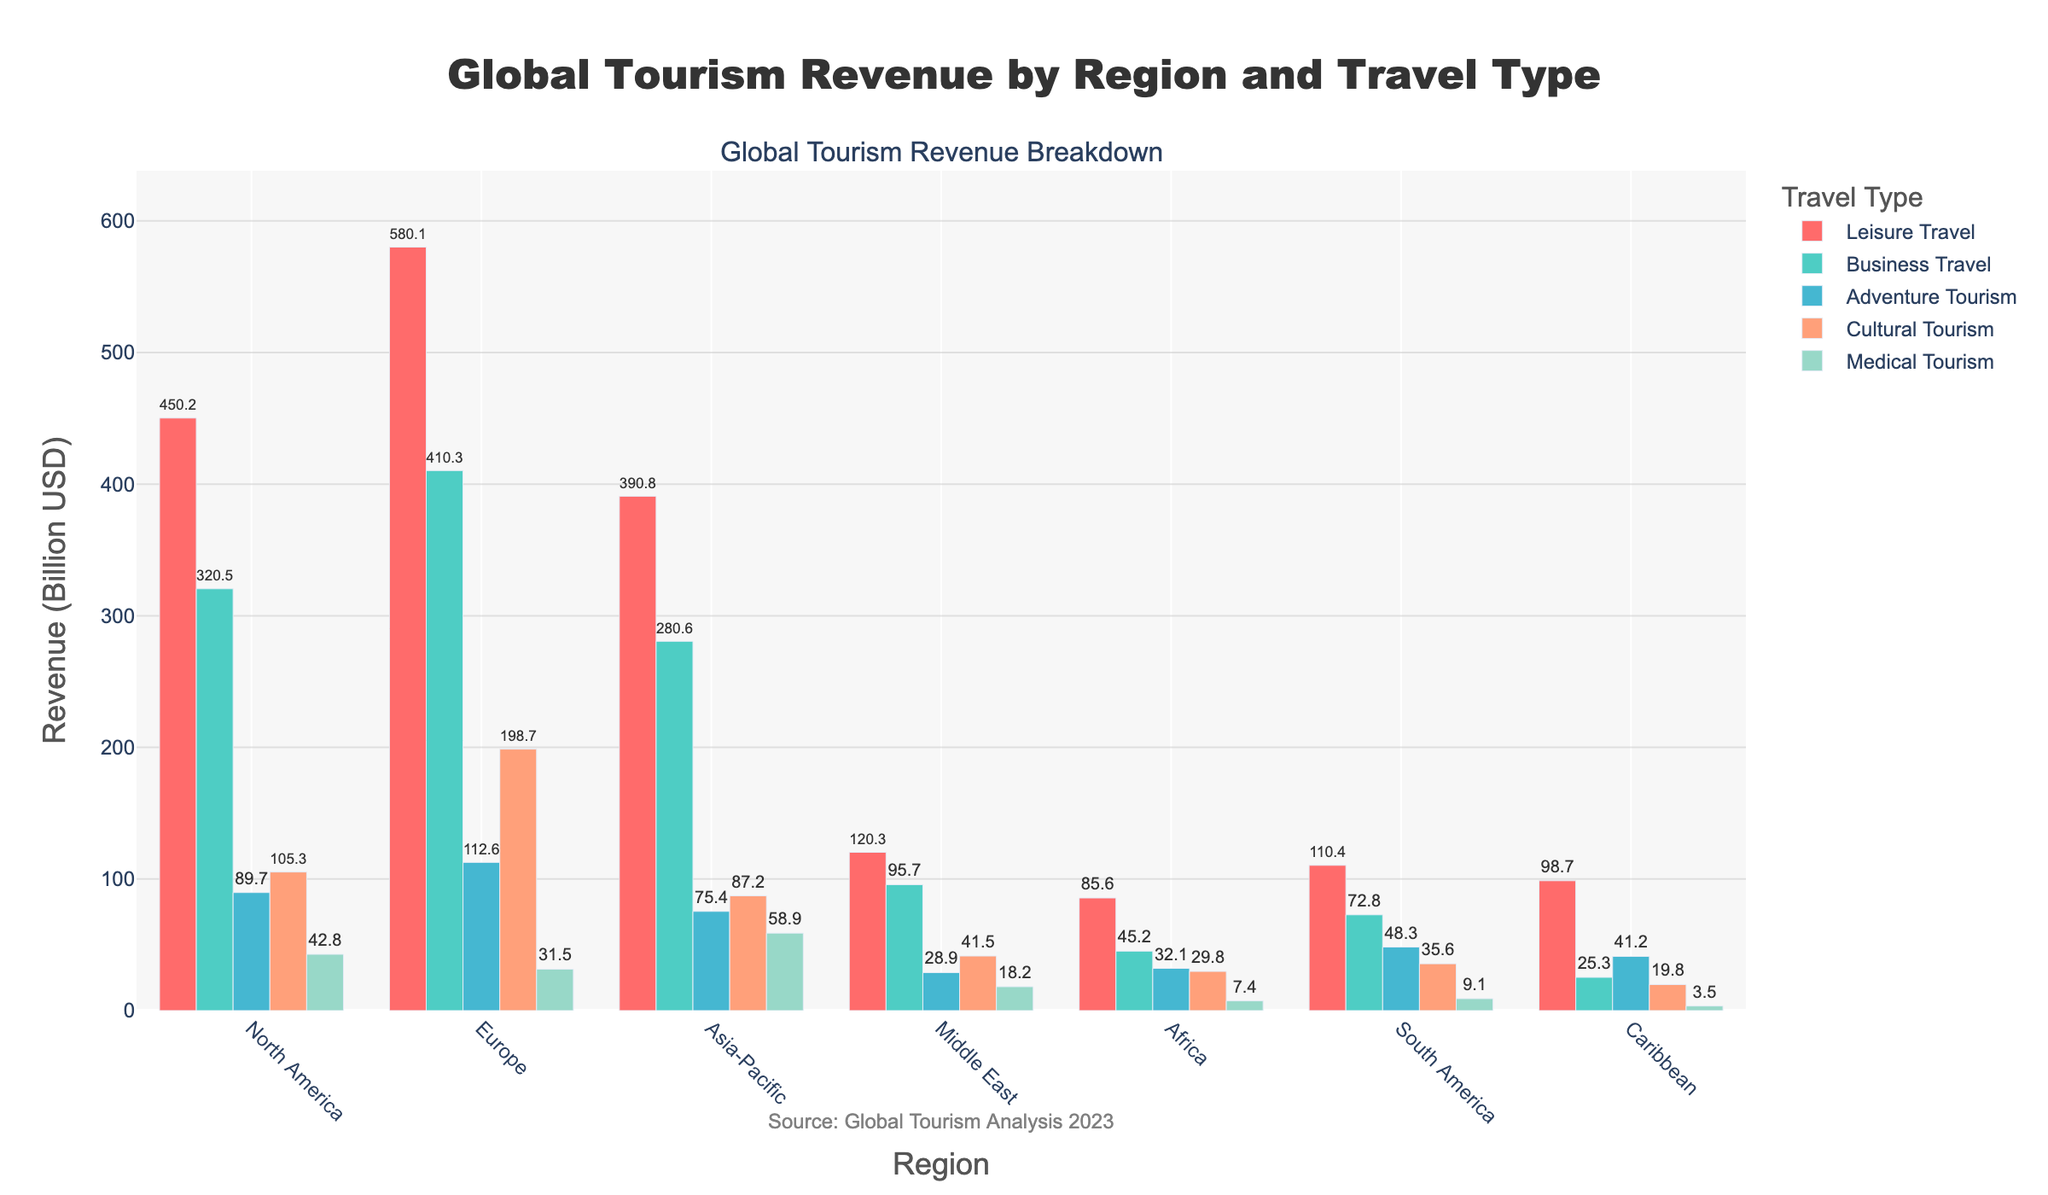What is the region with the highest revenue in Leisure Travel, and how much is it? To determine the region with the highest revenue in Leisure Travel, look at the height of the bars representing Leisure Travel. The tallest bar corresponds to Europe. The y-axis value at this point is 580.1 Billion USD.
Answer: Europe, 580.1 Billion USD Which travel type generates the least revenue in Africa? To find the travel type with the least revenue in Africa, compare the heights of the bars for each travel type in the African region. The shortest bar corresponds to Medical Tourism with 7.4 Billion USD.
Answer: Medical Tourism, 7.4 Billion USD How does the revenue from Business Travel in North America compare to that in Asia-Pacific? To compare Business Travel revenue between North America and Asia-Pacific, observe the related bars. North America's Business Travel bar is at 320.5 Billion USD, whereas Asia-Pacific's is at 280.6 Billion USD.
Answer: North America has higher Business Travel revenue What is the sum of revenues from Cultural Tourism for Europe and South America? Add the revenue values for Cultural Tourism from Europe and South America. For Europe, it is 198.7 Billion USD, and for South America, it is 35.6 Billion USD. Total is 198.7 + 35.6 = 234.3 Billion USD.
Answer: 234.3 Billion USD In which region is Adventure Tourism revenue higher than Business Travel revenue? Compare the heights of the bars for Adventure Tourism and Business Travel within each region. Only in Caribbean is Adventure Tourism (41.2 Billion USD) higher than Business Travel (25.3 Billion USD).
Answer: Caribbean What is the total revenue from Medical Tourism across all regions? Sum the revenue values for Medical Tourism from all regions: 42.8 (North America) + 31.5 (Europe) + 58.9 (Asia-Pacific) + 18.2 (Middle East) + 7.4 (Africa) + 9.1 (South America) + 3.5 (Caribbean) = 171.4 Billion USD.
Answer: 171.4 Billion USD How does the Medical Tourism revenue in Asia-Pacific compare to the same in Europe? Examine the bars for Medical Tourism in Asia-Pacific and Europe. Asia-Pacific's revenue is 58.9 Billion USD while Europe's is 31.5 Billion USD.
Answer: Higher in Asia-Pacific Which travel type contributes the most to total global tourism revenue from the visual data? Sum the revenue values for each travel type across all regions and compare. The tallest total set of bars belongs to Leisure Travel with 450.2 + 580.1 + 390.8 + 120.3 + 85.6 + 110.4 + 98.7 = 1836.1 Billion USD.
Answer: Leisure Travel 